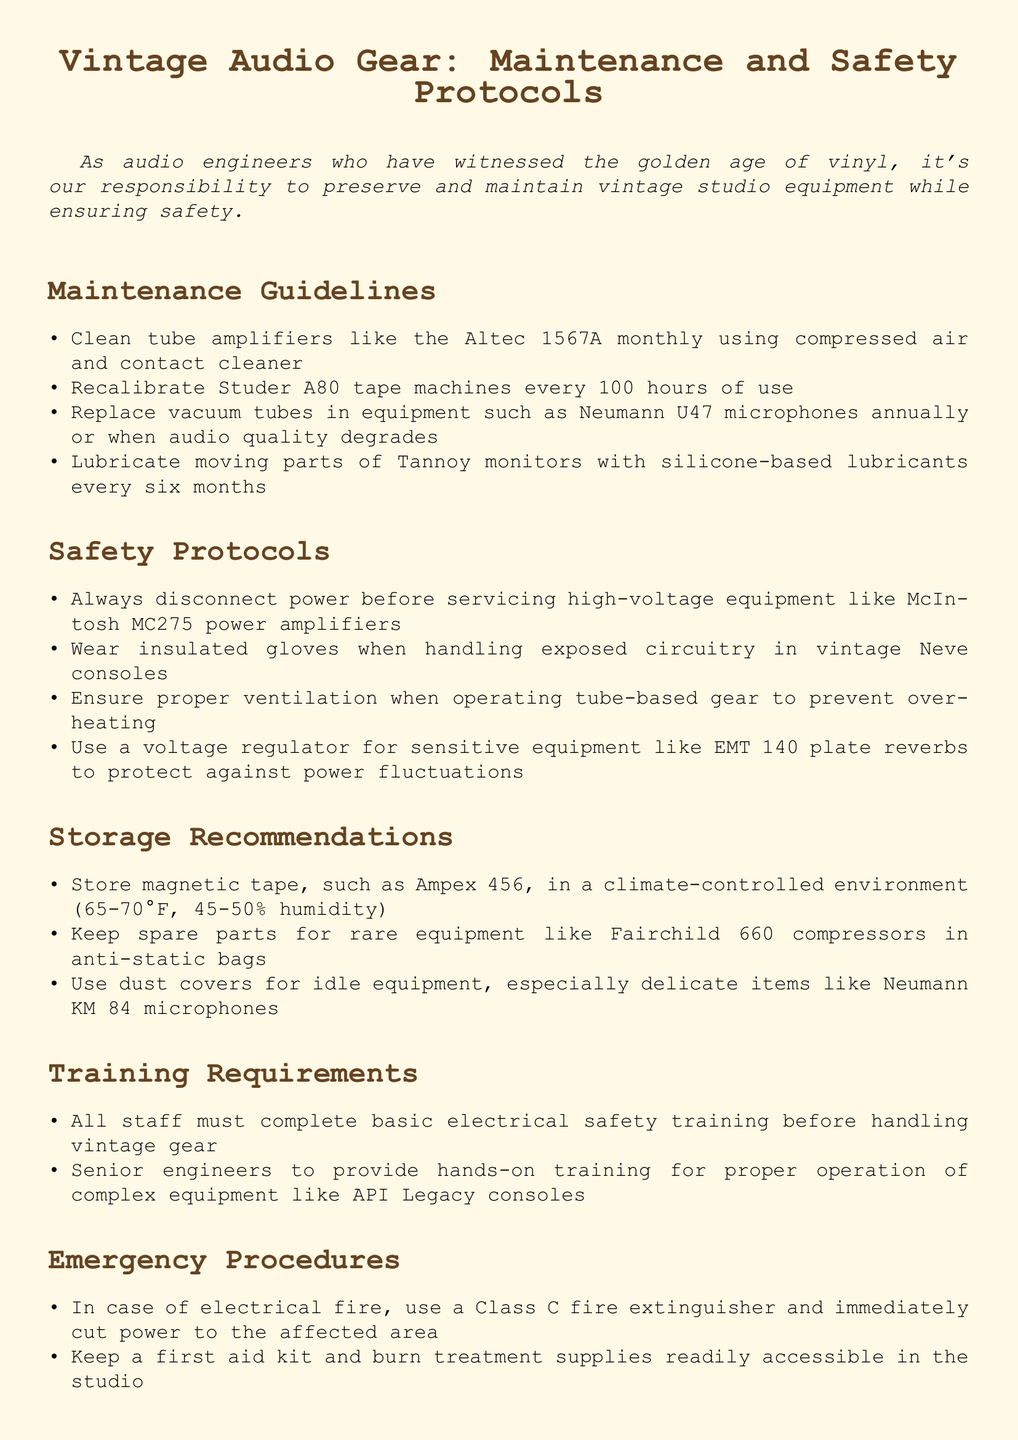What is the maintenance frequency for tube amplifiers like the Altec 1567A? The document states that tube amplifiers should be cleaned monthly.
Answer: monthly How often should the Studer A80 tape machines be recalibrated? The document mentions that they should be recalibrated every 100 hours of use.
Answer: 100 hours What is the recommended storage temperature for magnetic tape like Ampex 456? The document specifies a climate-controlled environment of 65-70°F.
Answer: 65-70°F What type of fire extinguisher should be used in case of an electrical fire? According to the document, a Class C fire extinguisher should be used.
Answer: Class C What specific safety equipment should staff wear when handling exposed circuitry? The document advises wearing insulated gloves.
Answer: insulated gloves What must all staff complete before handling vintage gear? The policy states that all staff must complete basic electrical safety training.
Answer: basic electrical safety training How often should moving parts of Tannoy monitors be lubricated? The document recommends lubricating them every six months.
Answer: every six months Who is responsible for providing hands-on training for complex equipment? The document states that senior engineers provide this training.
Answer: senior engineers What should be used to protect sensitive equipment against power fluctuations? A voltage regulator should be used, as mentioned in the document.
Answer: voltage regulator 